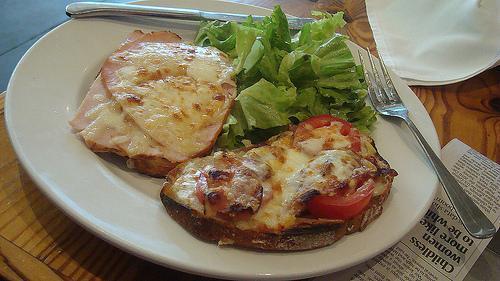How many forks are in the photo?
Give a very brief answer. 1. 